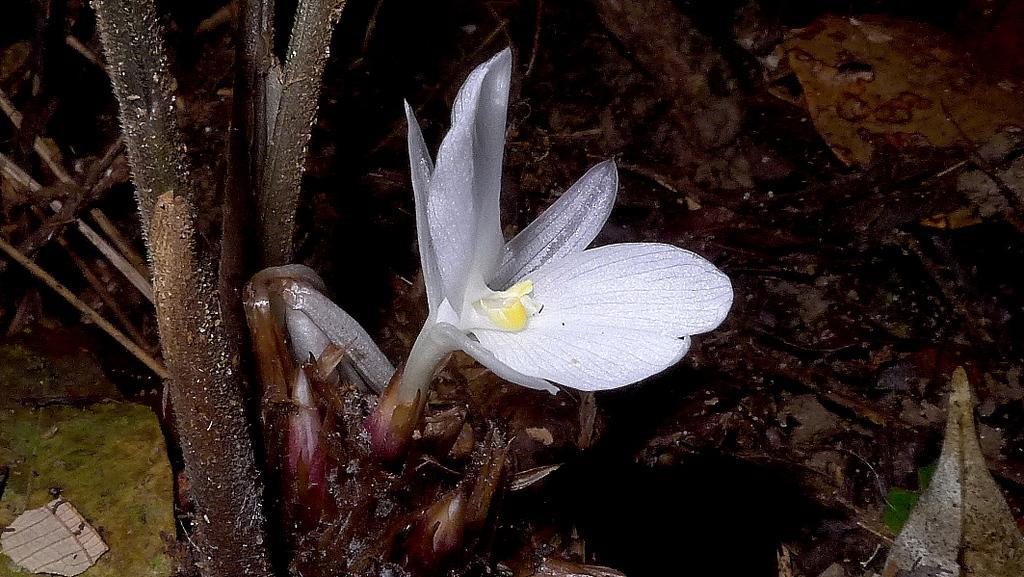Could you give a brief overview of what you see in this image? In this image we can see a white flower of a tree. 